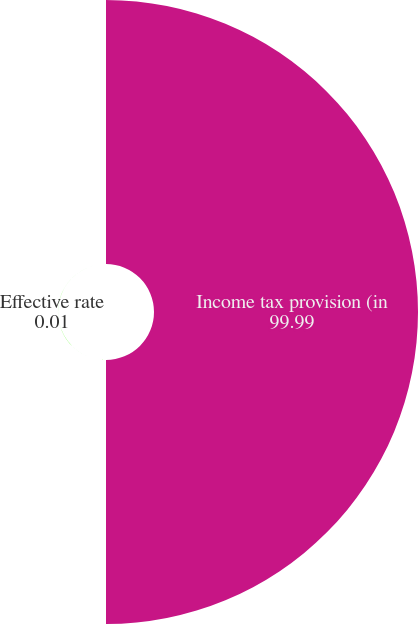Convert chart. <chart><loc_0><loc_0><loc_500><loc_500><pie_chart><fcel>Income tax provision (in<fcel>Effective rate<nl><fcel>99.99%<fcel>0.01%<nl></chart> 